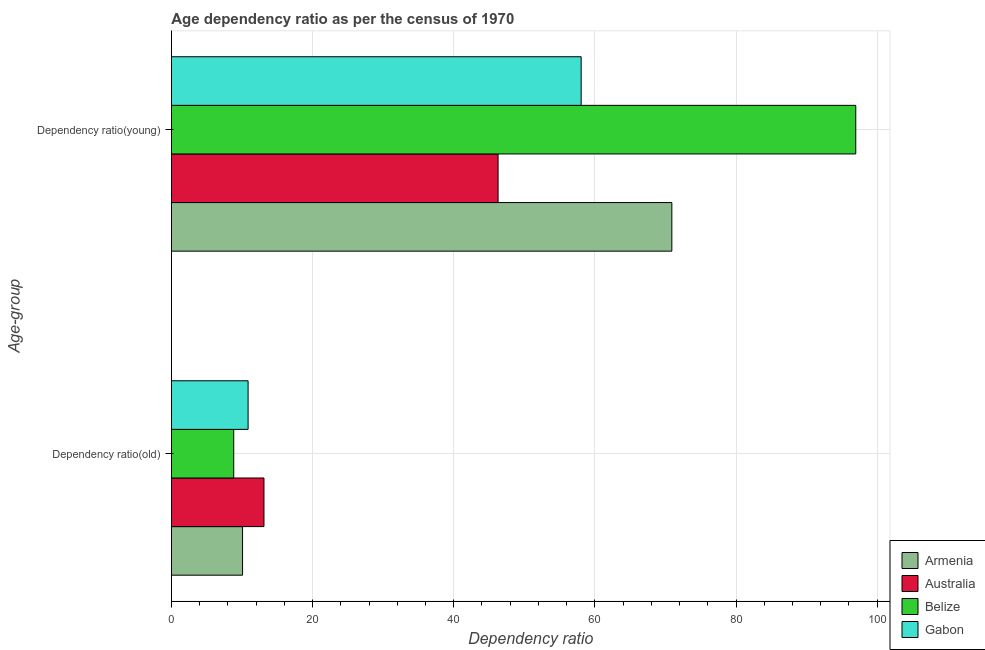How many different coloured bars are there?
Offer a very short reply. 4. Are the number of bars per tick equal to the number of legend labels?
Give a very brief answer. Yes. Are the number of bars on each tick of the Y-axis equal?
Your answer should be very brief. Yes. What is the label of the 2nd group of bars from the top?
Your answer should be very brief. Dependency ratio(old). What is the age dependency ratio(old) in Gabon?
Provide a succinct answer. 10.87. Across all countries, what is the maximum age dependency ratio(old)?
Your answer should be compact. 13.12. Across all countries, what is the minimum age dependency ratio(old)?
Give a very brief answer. 8.83. In which country was the age dependency ratio(old) minimum?
Your answer should be compact. Belize. What is the total age dependency ratio(old) in the graph?
Your response must be concise. 42.91. What is the difference between the age dependency ratio(old) in Gabon and that in Armenia?
Provide a short and direct response. 0.79. What is the difference between the age dependency ratio(young) in Armenia and the age dependency ratio(old) in Gabon?
Keep it short and to the point. 60.04. What is the average age dependency ratio(old) per country?
Provide a succinct answer. 10.73. What is the difference between the age dependency ratio(young) and age dependency ratio(old) in Australia?
Your response must be concise. 33.17. What is the ratio of the age dependency ratio(old) in Gabon to that in Australia?
Keep it short and to the point. 0.83. Is the age dependency ratio(young) in Belize less than that in Australia?
Keep it short and to the point. No. What does the 2nd bar from the bottom in Dependency ratio(young) represents?
Provide a short and direct response. Australia. How many countries are there in the graph?
Your answer should be very brief. 4. What is the difference between two consecutive major ticks on the X-axis?
Your answer should be very brief. 20. Are the values on the major ticks of X-axis written in scientific E-notation?
Give a very brief answer. No. Does the graph contain any zero values?
Provide a succinct answer. No. Does the graph contain grids?
Your answer should be compact. Yes. How many legend labels are there?
Your response must be concise. 4. How are the legend labels stacked?
Give a very brief answer. Vertical. What is the title of the graph?
Give a very brief answer. Age dependency ratio as per the census of 1970. What is the label or title of the X-axis?
Keep it short and to the point. Dependency ratio. What is the label or title of the Y-axis?
Keep it short and to the point. Age-group. What is the Dependency ratio of Armenia in Dependency ratio(old)?
Provide a succinct answer. 10.08. What is the Dependency ratio of Australia in Dependency ratio(old)?
Your answer should be very brief. 13.12. What is the Dependency ratio in Belize in Dependency ratio(old)?
Provide a short and direct response. 8.83. What is the Dependency ratio in Gabon in Dependency ratio(old)?
Your answer should be very brief. 10.87. What is the Dependency ratio in Armenia in Dependency ratio(young)?
Your response must be concise. 70.91. What is the Dependency ratio in Australia in Dependency ratio(young)?
Offer a terse response. 46.29. What is the Dependency ratio of Belize in Dependency ratio(young)?
Provide a succinct answer. 96.97. What is the Dependency ratio of Gabon in Dependency ratio(young)?
Keep it short and to the point. 58.06. Across all Age-group, what is the maximum Dependency ratio of Armenia?
Your answer should be compact. 70.91. Across all Age-group, what is the maximum Dependency ratio of Australia?
Offer a terse response. 46.29. Across all Age-group, what is the maximum Dependency ratio of Belize?
Offer a terse response. 96.97. Across all Age-group, what is the maximum Dependency ratio in Gabon?
Your response must be concise. 58.06. Across all Age-group, what is the minimum Dependency ratio of Armenia?
Give a very brief answer. 10.08. Across all Age-group, what is the minimum Dependency ratio in Australia?
Your answer should be very brief. 13.12. Across all Age-group, what is the minimum Dependency ratio of Belize?
Your answer should be compact. 8.83. Across all Age-group, what is the minimum Dependency ratio of Gabon?
Give a very brief answer. 10.87. What is the total Dependency ratio of Armenia in the graph?
Provide a succinct answer. 80.99. What is the total Dependency ratio of Australia in the graph?
Your response must be concise. 59.41. What is the total Dependency ratio in Belize in the graph?
Give a very brief answer. 105.8. What is the total Dependency ratio in Gabon in the graph?
Provide a succinct answer. 68.93. What is the difference between the Dependency ratio of Armenia in Dependency ratio(old) and that in Dependency ratio(young)?
Ensure brevity in your answer.  -60.82. What is the difference between the Dependency ratio of Australia in Dependency ratio(old) and that in Dependency ratio(young)?
Make the answer very short. -33.17. What is the difference between the Dependency ratio in Belize in Dependency ratio(old) and that in Dependency ratio(young)?
Ensure brevity in your answer.  -88.13. What is the difference between the Dependency ratio of Gabon in Dependency ratio(old) and that in Dependency ratio(young)?
Your answer should be very brief. -47.19. What is the difference between the Dependency ratio of Armenia in Dependency ratio(old) and the Dependency ratio of Australia in Dependency ratio(young)?
Keep it short and to the point. -36.2. What is the difference between the Dependency ratio of Armenia in Dependency ratio(old) and the Dependency ratio of Belize in Dependency ratio(young)?
Offer a very short reply. -86.88. What is the difference between the Dependency ratio of Armenia in Dependency ratio(old) and the Dependency ratio of Gabon in Dependency ratio(young)?
Give a very brief answer. -47.98. What is the difference between the Dependency ratio in Australia in Dependency ratio(old) and the Dependency ratio in Belize in Dependency ratio(young)?
Provide a succinct answer. -83.85. What is the difference between the Dependency ratio in Australia in Dependency ratio(old) and the Dependency ratio in Gabon in Dependency ratio(young)?
Provide a succinct answer. -44.94. What is the difference between the Dependency ratio in Belize in Dependency ratio(old) and the Dependency ratio in Gabon in Dependency ratio(young)?
Provide a succinct answer. -49.22. What is the average Dependency ratio in Armenia per Age-group?
Ensure brevity in your answer.  40.5. What is the average Dependency ratio in Australia per Age-group?
Provide a succinct answer. 29.7. What is the average Dependency ratio of Belize per Age-group?
Offer a terse response. 52.9. What is the average Dependency ratio of Gabon per Age-group?
Provide a succinct answer. 34.46. What is the difference between the Dependency ratio in Armenia and Dependency ratio in Australia in Dependency ratio(old)?
Offer a terse response. -3.03. What is the difference between the Dependency ratio of Armenia and Dependency ratio of Belize in Dependency ratio(old)?
Your answer should be very brief. 1.25. What is the difference between the Dependency ratio in Armenia and Dependency ratio in Gabon in Dependency ratio(old)?
Keep it short and to the point. -0.79. What is the difference between the Dependency ratio of Australia and Dependency ratio of Belize in Dependency ratio(old)?
Provide a short and direct response. 4.28. What is the difference between the Dependency ratio in Australia and Dependency ratio in Gabon in Dependency ratio(old)?
Make the answer very short. 2.25. What is the difference between the Dependency ratio of Belize and Dependency ratio of Gabon in Dependency ratio(old)?
Keep it short and to the point. -2.04. What is the difference between the Dependency ratio of Armenia and Dependency ratio of Australia in Dependency ratio(young)?
Offer a very short reply. 24.62. What is the difference between the Dependency ratio in Armenia and Dependency ratio in Belize in Dependency ratio(young)?
Your answer should be very brief. -26.06. What is the difference between the Dependency ratio in Armenia and Dependency ratio in Gabon in Dependency ratio(young)?
Provide a succinct answer. 12.85. What is the difference between the Dependency ratio in Australia and Dependency ratio in Belize in Dependency ratio(young)?
Offer a very short reply. -50.68. What is the difference between the Dependency ratio of Australia and Dependency ratio of Gabon in Dependency ratio(young)?
Provide a succinct answer. -11.77. What is the difference between the Dependency ratio in Belize and Dependency ratio in Gabon in Dependency ratio(young)?
Offer a very short reply. 38.91. What is the ratio of the Dependency ratio in Armenia in Dependency ratio(old) to that in Dependency ratio(young)?
Offer a very short reply. 0.14. What is the ratio of the Dependency ratio of Australia in Dependency ratio(old) to that in Dependency ratio(young)?
Your response must be concise. 0.28. What is the ratio of the Dependency ratio of Belize in Dependency ratio(old) to that in Dependency ratio(young)?
Your answer should be compact. 0.09. What is the ratio of the Dependency ratio in Gabon in Dependency ratio(old) to that in Dependency ratio(young)?
Provide a succinct answer. 0.19. What is the difference between the highest and the second highest Dependency ratio in Armenia?
Make the answer very short. 60.82. What is the difference between the highest and the second highest Dependency ratio in Australia?
Your answer should be very brief. 33.17. What is the difference between the highest and the second highest Dependency ratio in Belize?
Keep it short and to the point. 88.13. What is the difference between the highest and the second highest Dependency ratio of Gabon?
Give a very brief answer. 47.19. What is the difference between the highest and the lowest Dependency ratio of Armenia?
Provide a short and direct response. 60.82. What is the difference between the highest and the lowest Dependency ratio of Australia?
Make the answer very short. 33.17. What is the difference between the highest and the lowest Dependency ratio of Belize?
Your answer should be very brief. 88.13. What is the difference between the highest and the lowest Dependency ratio of Gabon?
Provide a short and direct response. 47.19. 